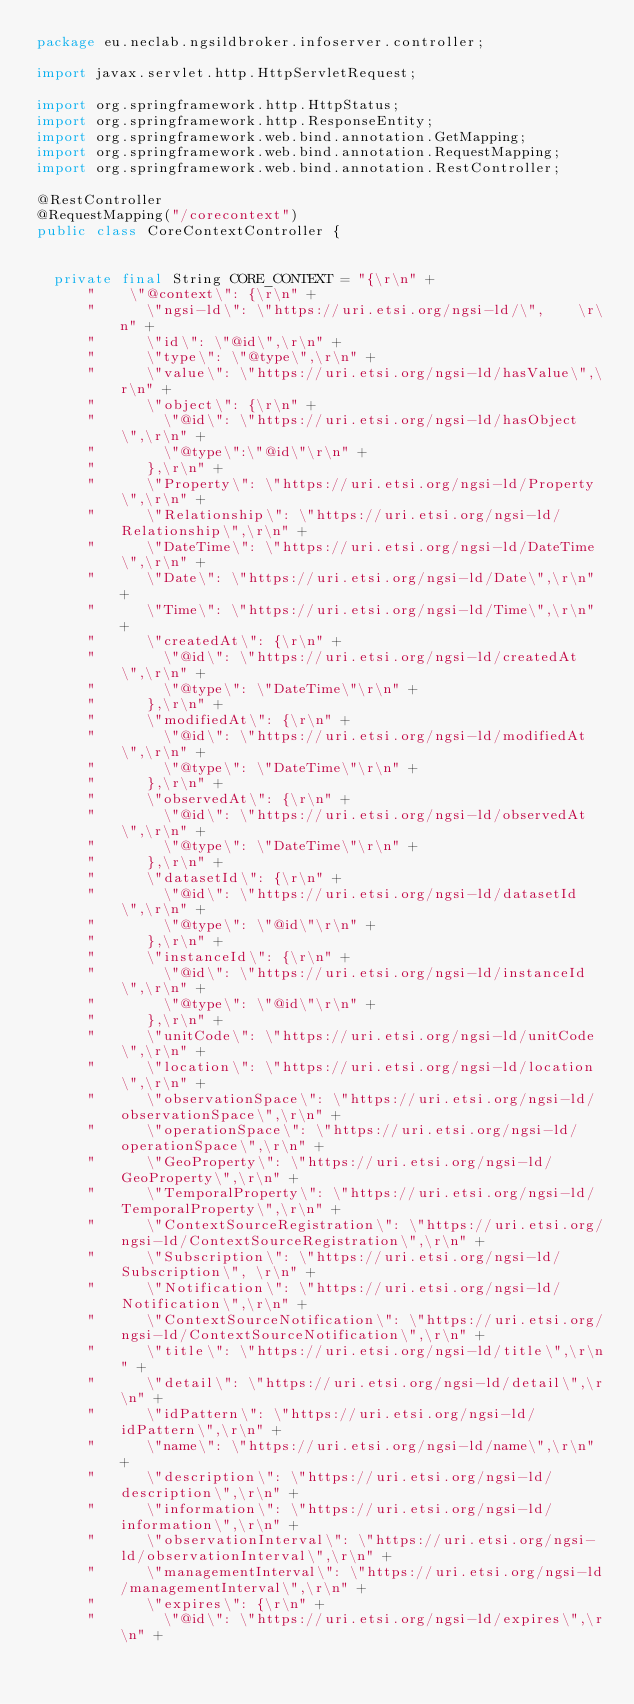Convert code to text. <code><loc_0><loc_0><loc_500><loc_500><_Java_>package eu.neclab.ngsildbroker.infoserver.controller;

import javax.servlet.http.HttpServletRequest;

import org.springframework.http.HttpStatus;
import org.springframework.http.ResponseEntity;
import org.springframework.web.bind.annotation.GetMapping;
import org.springframework.web.bind.annotation.RequestMapping;
import org.springframework.web.bind.annotation.RestController;

@RestController
@RequestMapping("/corecontext")
public class CoreContextController {
	

	private final String CORE_CONTEXT = "{\r\n" + 
			"    \"@context\": {\r\n" + 
			"      \"ngsi-ld\": \"https://uri.etsi.org/ngsi-ld/\",    \r\n" + 
			"      \"id\": \"@id\",\r\n" + 
			"      \"type\": \"@type\",\r\n" + 
			"      \"value\": \"https://uri.etsi.org/ngsi-ld/hasValue\",\r\n" + 
			"      \"object\": {\r\n" + 
			"        \"@id\": \"https://uri.etsi.org/ngsi-ld/hasObject\",\r\n" + 
			"        \"@type\":\"@id\"\r\n" + 
			"      },\r\n" + 
			"      \"Property\": \"https://uri.etsi.org/ngsi-ld/Property\",\r\n" + 
			"      \"Relationship\": \"https://uri.etsi.org/ngsi-ld/Relationship\",\r\n" + 
			"      \"DateTime\": \"https://uri.etsi.org/ngsi-ld/DateTime\",\r\n" + 
			"      \"Date\": \"https://uri.etsi.org/ngsi-ld/Date\",\r\n" + 
			"      \"Time\": \"https://uri.etsi.org/ngsi-ld/Time\",\r\n" + 
			"      \"createdAt\": {\r\n" + 
			"        \"@id\": \"https://uri.etsi.org/ngsi-ld/createdAt\",\r\n" + 
			"        \"@type\": \"DateTime\"\r\n" + 
			"      },\r\n" + 
			"      \"modifiedAt\": {\r\n" + 
			"        \"@id\": \"https://uri.etsi.org/ngsi-ld/modifiedAt\",\r\n" + 
			"        \"@type\": \"DateTime\"\r\n" + 
			"      },\r\n" + 
			"      \"observedAt\": {\r\n" + 
			"        \"@id\": \"https://uri.etsi.org/ngsi-ld/observedAt\",\r\n" + 
			"        \"@type\": \"DateTime\"\r\n" + 
			"      },\r\n" + 
			"      \"datasetId\": {\r\n" + 
			"        \"@id\": \"https://uri.etsi.org/ngsi-ld/datasetId\",\r\n" + 
			"        \"@type\": \"@id\"\r\n" + 
			"      },\r\n" + 
			"      \"instanceId\": {\r\n" + 
			"        \"@id\": \"https://uri.etsi.org/ngsi-ld/instanceId\",\r\n" + 
			"        \"@type\": \"@id\"\r\n" + 
			"      },\r\n" + 
			"      \"unitCode\": \"https://uri.etsi.org/ngsi-ld/unitCode\",\r\n" + 
			"      \"location\": \"https://uri.etsi.org/ngsi-ld/location\",\r\n" + 
			"      \"observationSpace\": \"https://uri.etsi.org/ngsi-ld/observationSpace\",\r\n" + 
			"      \"operationSpace\": \"https://uri.etsi.org/ngsi-ld/operationSpace\",\r\n" + 
			"      \"GeoProperty\": \"https://uri.etsi.org/ngsi-ld/GeoProperty\",\r\n" + 
			"      \"TemporalProperty\": \"https://uri.etsi.org/ngsi-ld/TemporalProperty\",\r\n" + 
			"      \"ContextSourceRegistration\": \"https://uri.etsi.org/ngsi-ld/ContextSourceRegistration\",\r\n" + 
			"      \"Subscription\": \"https://uri.etsi.org/ngsi-ld/Subscription\", \r\n" + 
			"      \"Notification\": \"https://uri.etsi.org/ngsi-ld/Notification\",\r\n" + 
			"      \"ContextSourceNotification\": \"https://uri.etsi.org/ngsi-ld/ContextSourceNotification\",\r\n" + 
			"      \"title\": \"https://uri.etsi.org/ngsi-ld/title\",\r\n" + 
			"      \"detail\": \"https://uri.etsi.org/ngsi-ld/detail\",\r\n" + 
			"      \"idPattern\": \"https://uri.etsi.org/ngsi-ld/idPattern\",\r\n" + 
			"      \"name\": \"https://uri.etsi.org/ngsi-ld/name\",\r\n" + 
			"      \"description\": \"https://uri.etsi.org/ngsi-ld/description\",\r\n" + 
			"      \"information\": \"https://uri.etsi.org/ngsi-ld/information\",\r\n" + 
			"      \"observationInterval\": \"https://uri.etsi.org/ngsi-ld/observationInterval\",\r\n" + 
			"      \"managementInterval\": \"https://uri.etsi.org/ngsi-ld/managementInterval\",\r\n" + 
			"      \"expires\": {\r\n" + 
			"        \"@id\": \"https://uri.etsi.org/ngsi-ld/expires\",\r\n" + </code> 